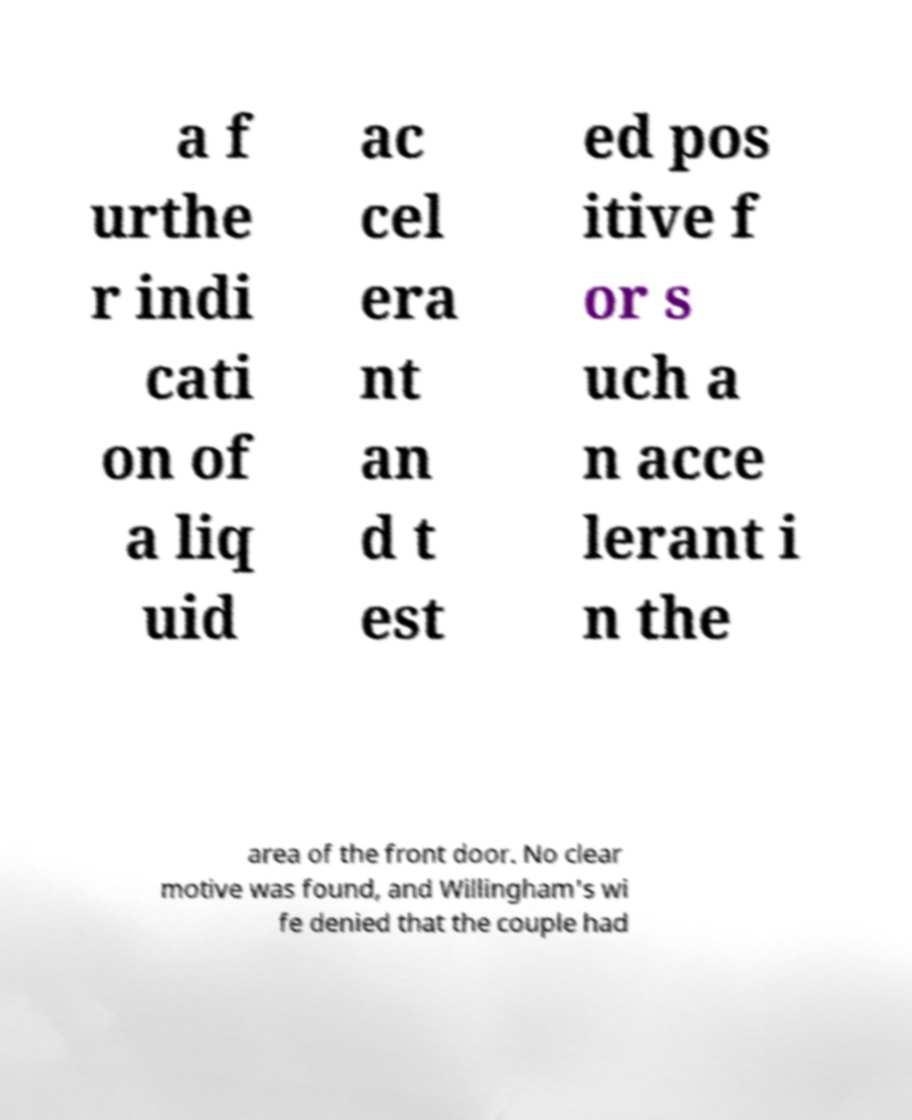There's text embedded in this image that I need extracted. Can you transcribe it verbatim? a f urthe r indi cati on of a liq uid ac cel era nt an d t est ed pos itive f or s uch a n acce lerant i n the area of the front door. No clear motive was found, and Willingham's wi fe denied that the couple had 